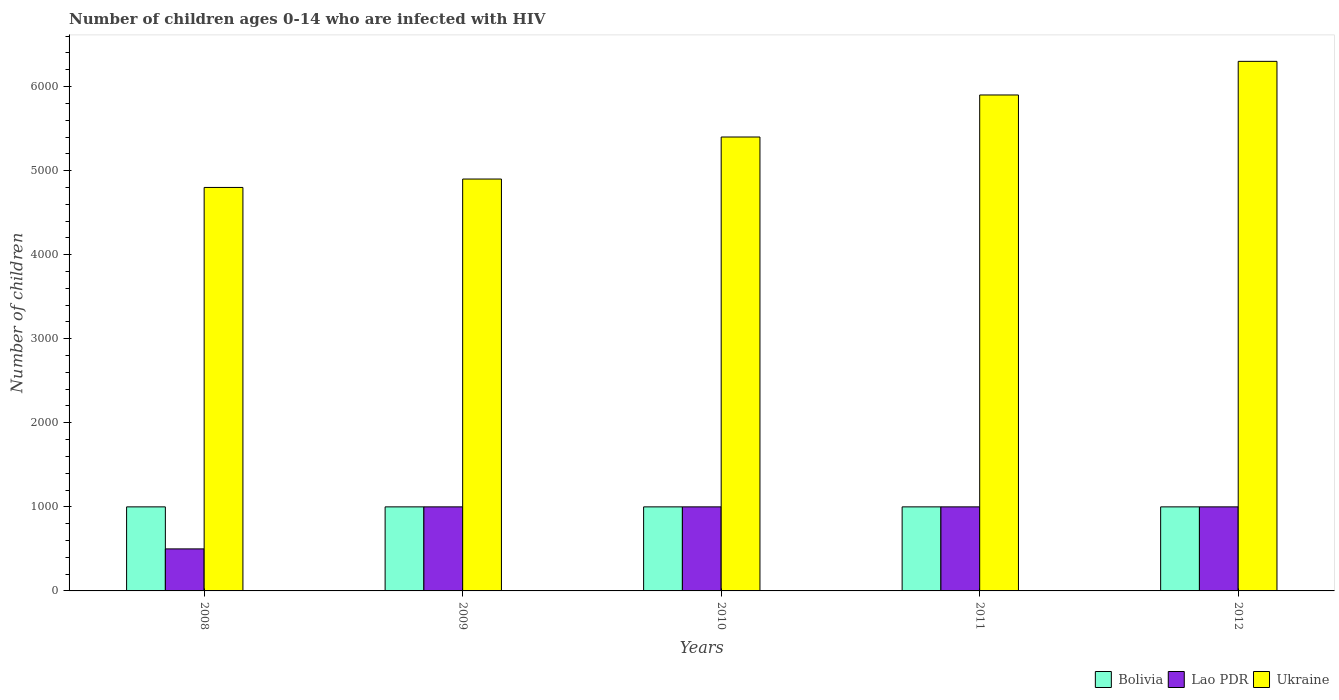How many different coloured bars are there?
Your answer should be compact. 3. How many groups of bars are there?
Provide a short and direct response. 5. Are the number of bars per tick equal to the number of legend labels?
Provide a succinct answer. Yes. Are the number of bars on each tick of the X-axis equal?
Offer a very short reply. Yes. What is the label of the 2nd group of bars from the left?
Provide a succinct answer. 2009. In how many cases, is the number of bars for a given year not equal to the number of legend labels?
Offer a terse response. 0. What is the number of HIV infected children in Lao PDR in 2008?
Keep it short and to the point. 500. Across all years, what is the maximum number of HIV infected children in Bolivia?
Offer a terse response. 1000. Across all years, what is the minimum number of HIV infected children in Bolivia?
Give a very brief answer. 1000. What is the total number of HIV infected children in Bolivia in the graph?
Ensure brevity in your answer.  5000. What is the difference between the number of HIV infected children in Ukraine in 2010 and that in 2011?
Provide a short and direct response. -500. What is the difference between the number of HIV infected children in Bolivia in 2011 and the number of HIV infected children in Ukraine in 2009?
Make the answer very short. -3900. What is the average number of HIV infected children in Bolivia per year?
Provide a short and direct response. 1000. In the year 2011, what is the difference between the number of HIV infected children in Ukraine and number of HIV infected children in Bolivia?
Your answer should be very brief. 4900. In how many years, is the number of HIV infected children in Ukraine greater than 5800?
Your response must be concise. 2. Is the number of HIV infected children in Ukraine in 2009 less than that in 2011?
Your response must be concise. Yes. What is the difference between the highest and the lowest number of HIV infected children in Lao PDR?
Your answer should be compact. 500. Is the sum of the number of HIV infected children in Lao PDR in 2009 and 2010 greater than the maximum number of HIV infected children in Ukraine across all years?
Offer a terse response. No. What does the 2nd bar from the left in 2011 represents?
Offer a terse response. Lao PDR. What does the 3rd bar from the right in 2012 represents?
Your answer should be very brief. Bolivia. What is the difference between two consecutive major ticks on the Y-axis?
Keep it short and to the point. 1000. Are the values on the major ticks of Y-axis written in scientific E-notation?
Ensure brevity in your answer.  No. Does the graph contain any zero values?
Provide a succinct answer. No. Does the graph contain grids?
Offer a very short reply. No. Where does the legend appear in the graph?
Ensure brevity in your answer.  Bottom right. How are the legend labels stacked?
Offer a terse response. Horizontal. What is the title of the graph?
Ensure brevity in your answer.  Number of children ages 0-14 who are infected with HIV. Does "Sub-Saharan Africa (developing only)" appear as one of the legend labels in the graph?
Make the answer very short. No. What is the label or title of the X-axis?
Your answer should be very brief. Years. What is the label or title of the Y-axis?
Give a very brief answer. Number of children. What is the Number of children in Ukraine in 2008?
Make the answer very short. 4800. What is the Number of children of Lao PDR in 2009?
Keep it short and to the point. 1000. What is the Number of children of Ukraine in 2009?
Provide a succinct answer. 4900. What is the Number of children of Bolivia in 2010?
Keep it short and to the point. 1000. What is the Number of children in Ukraine in 2010?
Ensure brevity in your answer.  5400. What is the Number of children in Bolivia in 2011?
Offer a terse response. 1000. What is the Number of children in Ukraine in 2011?
Ensure brevity in your answer.  5900. What is the Number of children of Bolivia in 2012?
Your answer should be compact. 1000. What is the Number of children of Lao PDR in 2012?
Keep it short and to the point. 1000. What is the Number of children in Ukraine in 2012?
Provide a short and direct response. 6300. Across all years, what is the maximum Number of children of Bolivia?
Provide a short and direct response. 1000. Across all years, what is the maximum Number of children in Lao PDR?
Your answer should be very brief. 1000. Across all years, what is the maximum Number of children of Ukraine?
Keep it short and to the point. 6300. Across all years, what is the minimum Number of children of Bolivia?
Make the answer very short. 1000. Across all years, what is the minimum Number of children in Lao PDR?
Your answer should be very brief. 500. Across all years, what is the minimum Number of children of Ukraine?
Your answer should be very brief. 4800. What is the total Number of children in Bolivia in the graph?
Your answer should be compact. 5000. What is the total Number of children of Lao PDR in the graph?
Make the answer very short. 4500. What is the total Number of children in Ukraine in the graph?
Your answer should be very brief. 2.73e+04. What is the difference between the Number of children in Bolivia in 2008 and that in 2009?
Keep it short and to the point. 0. What is the difference between the Number of children in Lao PDR in 2008 and that in 2009?
Your answer should be compact. -500. What is the difference between the Number of children of Ukraine in 2008 and that in 2009?
Your answer should be very brief. -100. What is the difference between the Number of children in Bolivia in 2008 and that in 2010?
Your response must be concise. 0. What is the difference between the Number of children of Lao PDR in 2008 and that in 2010?
Give a very brief answer. -500. What is the difference between the Number of children of Ukraine in 2008 and that in 2010?
Make the answer very short. -600. What is the difference between the Number of children in Lao PDR in 2008 and that in 2011?
Ensure brevity in your answer.  -500. What is the difference between the Number of children of Ukraine in 2008 and that in 2011?
Ensure brevity in your answer.  -1100. What is the difference between the Number of children of Lao PDR in 2008 and that in 2012?
Make the answer very short. -500. What is the difference between the Number of children of Ukraine in 2008 and that in 2012?
Offer a very short reply. -1500. What is the difference between the Number of children in Bolivia in 2009 and that in 2010?
Provide a short and direct response. 0. What is the difference between the Number of children of Lao PDR in 2009 and that in 2010?
Keep it short and to the point. 0. What is the difference between the Number of children of Ukraine in 2009 and that in 2010?
Your answer should be very brief. -500. What is the difference between the Number of children in Lao PDR in 2009 and that in 2011?
Give a very brief answer. 0. What is the difference between the Number of children of Ukraine in 2009 and that in 2011?
Offer a very short reply. -1000. What is the difference between the Number of children of Bolivia in 2009 and that in 2012?
Provide a short and direct response. 0. What is the difference between the Number of children in Ukraine in 2009 and that in 2012?
Offer a very short reply. -1400. What is the difference between the Number of children in Bolivia in 2010 and that in 2011?
Your response must be concise. 0. What is the difference between the Number of children in Ukraine in 2010 and that in 2011?
Provide a succinct answer. -500. What is the difference between the Number of children in Lao PDR in 2010 and that in 2012?
Your response must be concise. 0. What is the difference between the Number of children in Ukraine in 2010 and that in 2012?
Your answer should be very brief. -900. What is the difference between the Number of children of Lao PDR in 2011 and that in 2012?
Offer a terse response. 0. What is the difference between the Number of children in Ukraine in 2011 and that in 2012?
Keep it short and to the point. -400. What is the difference between the Number of children of Bolivia in 2008 and the Number of children of Ukraine in 2009?
Make the answer very short. -3900. What is the difference between the Number of children in Lao PDR in 2008 and the Number of children in Ukraine in 2009?
Make the answer very short. -4400. What is the difference between the Number of children of Bolivia in 2008 and the Number of children of Ukraine in 2010?
Your answer should be compact. -4400. What is the difference between the Number of children in Lao PDR in 2008 and the Number of children in Ukraine in 2010?
Make the answer very short. -4900. What is the difference between the Number of children in Bolivia in 2008 and the Number of children in Ukraine in 2011?
Give a very brief answer. -4900. What is the difference between the Number of children in Lao PDR in 2008 and the Number of children in Ukraine in 2011?
Your answer should be compact. -5400. What is the difference between the Number of children of Bolivia in 2008 and the Number of children of Ukraine in 2012?
Provide a short and direct response. -5300. What is the difference between the Number of children of Lao PDR in 2008 and the Number of children of Ukraine in 2012?
Give a very brief answer. -5800. What is the difference between the Number of children of Bolivia in 2009 and the Number of children of Ukraine in 2010?
Give a very brief answer. -4400. What is the difference between the Number of children of Lao PDR in 2009 and the Number of children of Ukraine in 2010?
Give a very brief answer. -4400. What is the difference between the Number of children in Bolivia in 2009 and the Number of children in Lao PDR in 2011?
Your response must be concise. 0. What is the difference between the Number of children of Bolivia in 2009 and the Number of children of Ukraine in 2011?
Your answer should be compact. -4900. What is the difference between the Number of children in Lao PDR in 2009 and the Number of children in Ukraine in 2011?
Your response must be concise. -4900. What is the difference between the Number of children of Bolivia in 2009 and the Number of children of Ukraine in 2012?
Provide a succinct answer. -5300. What is the difference between the Number of children in Lao PDR in 2009 and the Number of children in Ukraine in 2012?
Your answer should be very brief. -5300. What is the difference between the Number of children in Bolivia in 2010 and the Number of children in Ukraine in 2011?
Provide a short and direct response. -4900. What is the difference between the Number of children of Lao PDR in 2010 and the Number of children of Ukraine in 2011?
Give a very brief answer. -4900. What is the difference between the Number of children in Bolivia in 2010 and the Number of children in Ukraine in 2012?
Provide a short and direct response. -5300. What is the difference between the Number of children in Lao PDR in 2010 and the Number of children in Ukraine in 2012?
Keep it short and to the point. -5300. What is the difference between the Number of children in Bolivia in 2011 and the Number of children in Ukraine in 2012?
Provide a succinct answer. -5300. What is the difference between the Number of children in Lao PDR in 2011 and the Number of children in Ukraine in 2012?
Provide a short and direct response. -5300. What is the average Number of children in Lao PDR per year?
Make the answer very short. 900. What is the average Number of children in Ukraine per year?
Your answer should be compact. 5460. In the year 2008, what is the difference between the Number of children in Bolivia and Number of children in Ukraine?
Keep it short and to the point. -3800. In the year 2008, what is the difference between the Number of children of Lao PDR and Number of children of Ukraine?
Keep it short and to the point. -4300. In the year 2009, what is the difference between the Number of children in Bolivia and Number of children in Lao PDR?
Offer a terse response. 0. In the year 2009, what is the difference between the Number of children in Bolivia and Number of children in Ukraine?
Give a very brief answer. -3900. In the year 2009, what is the difference between the Number of children of Lao PDR and Number of children of Ukraine?
Provide a succinct answer. -3900. In the year 2010, what is the difference between the Number of children of Bolivia and Number of children of Lao PDR?
Keep it short and to the point. 0. In the year 2010, what is the difference between the Number of children in Bolivia and Number of children in Ukraine?
Give a very brief answer. -4400. In the year 2010, what is the difference between the Number of children of Lao PDR and Number of children of Ukraine?
Keep it short and to the point. -4400. In the year 2011, what is the difference between the Number of children of Bolivia and Number of children of Ukraine?
Offer a terse response. -4900. In the year 2011, what is the difference between the Number of children of Lao PDR and Number of children of Ukraine?
Ensure brevity in your answer.  -4900. In the year 2012, what is the difference between the Number of children in Bolivia and Number of children in Lao PDR?
Give a very brief answer. 0. In the year 2012, what is the difference between the Number of children of Bolivia and Number of children of Ukraine?
Offer a very short reply. -5300. In the year 2012, what is the difference between the Number of children of Lao PDR and Number of children of Ukraine?
Make the answer very short. -5300. What is the ratio of the Number of children of Lao PDR in 2008 to that in 2009?
Your answer should be compact. 0.5. What is the ratio of the Number of children in Ukraine in 2008 to that in 2009?
Ensure brevity in your answer.  0.98. What is the ratio of the Number of children of Lao PDR in 2008 to that in 2010?
Provide a short and direct response. 0.5. What is the ratio of the Number of children of Ukraine in 2008 to that in 2010?
Your answer should be very brief. 0.89. What is the ratio of the Number of children of Bolivia in 2008 to that in 2011?
Your response must be concise. 1. What is the ratio of the Number of children in Lao PDR in 2008 to that in 2011?
Ensure brevity in your answer.  0.5. What is the ratio of the Number of children in Ukraine in 2008 to that in 2011?
Offer a terse response. 0.81. What is the ratio of the Number of children of Bolivia in 2008 to that in 2012?
Offer a very short reply. 1. What is the ratio of the Number of children in Ukraine in 2008 to that in 2012?
Offer a terse response. 0.76. What is the ratio of the Number of children of Lao PDR in 2009 to that in 2010?
Your answer should be very brief. 1. What is the ratio of the Number of children of Ukraine in 2009 to that in 2010?
Your response must be concise. 0.91. What is the ratio of the Number of children of Bolivia in 2009 to that in 2011?
Provide a succinct answer. 1. What is the ratio of the Number of children in Ukraine in 2009 to that in 2011?
Your response must be concise. 0.83. What is the ratio of the Number of children in Bolivia in 2009 to that in 2012?
Offer a very short reply. 1. What is the ratio of the Number of children of Lao PDR in 2009 to that in 2012?
Your answer should be compact. 1. What is the ratio of the Number of children in Ukraine in 2009 to that in 2012?
Provide a short and direct response. 0.78. What is the ratio of the Number of children of Bolivia in 2010 to that in 2011?
Provide a short and direct response. 1. What is the ratio of the Number of children of Lao PDR in 2010 to that in 2011?
Offer a very short reply. 1. What is the ratio of the Number of children of Ukraine in 2010 to that in 2011?
Keep it short and to the point. 0.92. What is the ratio of the Number of children in Bolivia in 2010 to that in 2012?
Keep it short and to the point. 1. What is the ratio of the Number of children in Lao PDR in 2010 to that in 2012?
Your answer should be very brief. 1. What is the ratio of the Number of children of Ukraine in 2011 to that in 2012?
Your response must be concise. 0.94. What is the difference between the highest and the second highest Number of children of Lao PDR?
Ensure brevity in your answer.  0. What is the difference between the highest and the lowest Number of children of Ukraine?
Provide a short and direct response. 1500. 